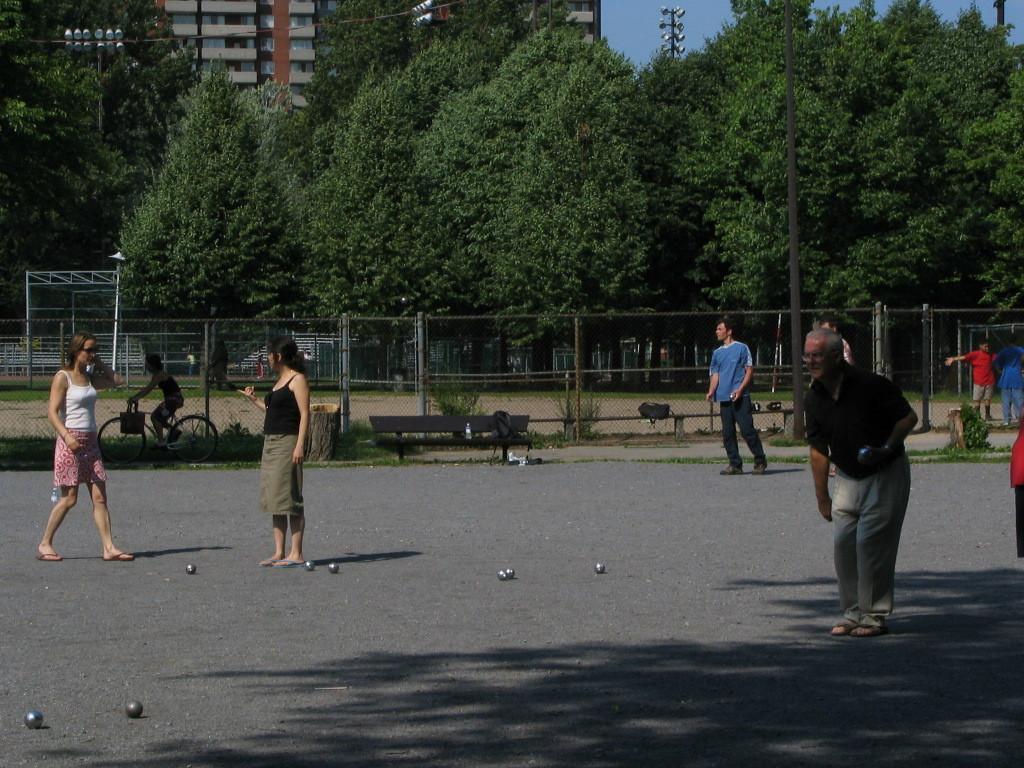Could you give a brief overview of what you see in this image? People and balls are on the road. Background there is a fence, benches, trees, light poles and building. A person is sitting on a bicycle. To this bicycle there is a bag.  